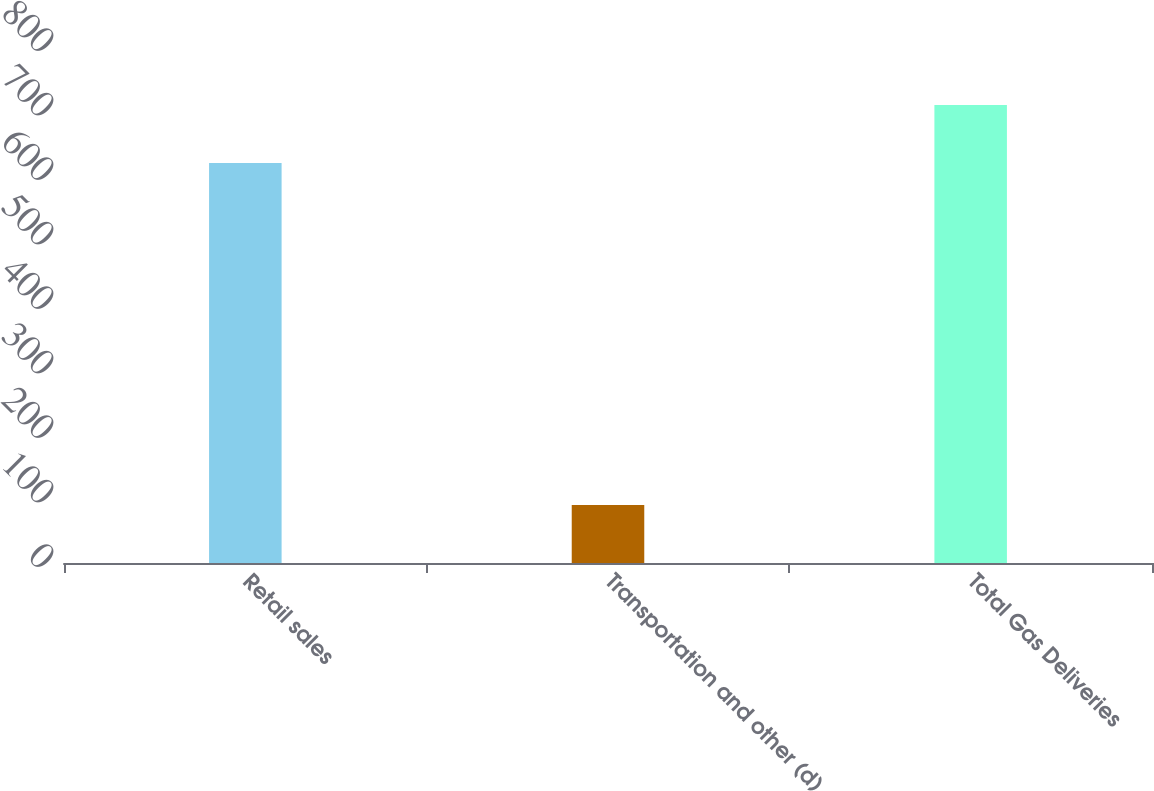Convert chart. <chart><loc_0><loc_0><loc_500><loc_500><bar_chart><fcel>Retail sales<fcel>Transportation and other (d)<fcel>Total Gas Deliveries<nl><fcel>620<fcel>90<fcel>710<nl></chart> 